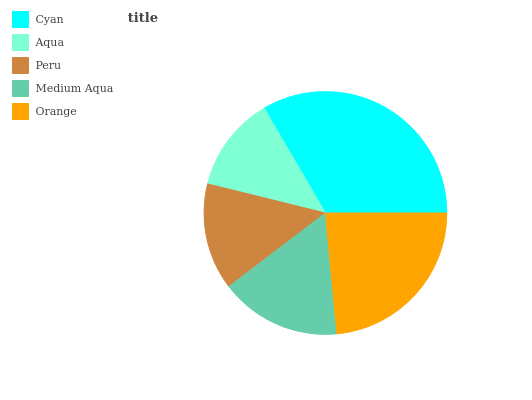Is Aqua the minimum?
Answer yes or no. Yes. Is Cyan the maximum?
Answer yes or no. Yes. Is Peru the minimum?
Answer yes or no. No. Is Peru the maximum?
Answer yes or no. No. Is Peru greater than Aqua?
Answer yes or no. Yes. Is Aqua less than Peru?
Answer yes or no. Yes. Is Aqua greater than Peru?
Answer yes or no. No. Is Peru less than Aqua?
Answer yes or no. No. Is Medium Aqua the high median?
Answer yes or no. Yes. Is Medium Aqua the low median?
Answer yes or no. Yes. Is Aqua the high median?
Answer yes or no. No. Is Peru the low median?
Answer yes or no. No. 